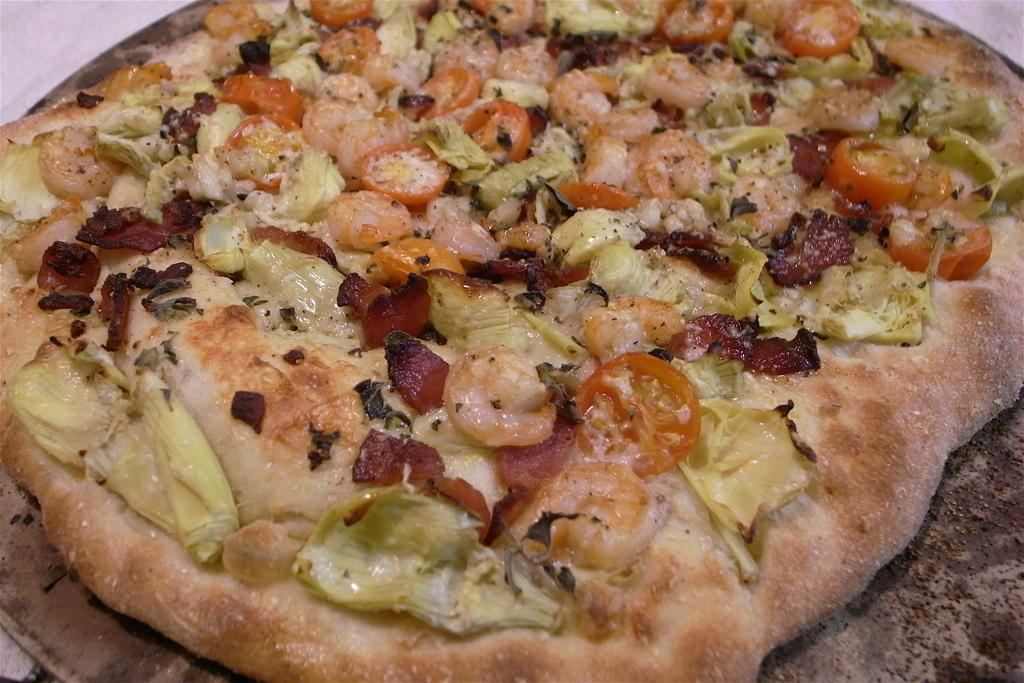What type of food is the main subject of the image? There is a pizza in the image. What specific ingredients can be seen on the pizza? The pizza has tomatoes, cabbage, and onions on it. Where is the light located in the image? The light is at the bottom of the image. How does the pizza transport itself to the store in the image? The pizza does not transport itself to a store in the image; it is a static image of a pizza with toppings. 